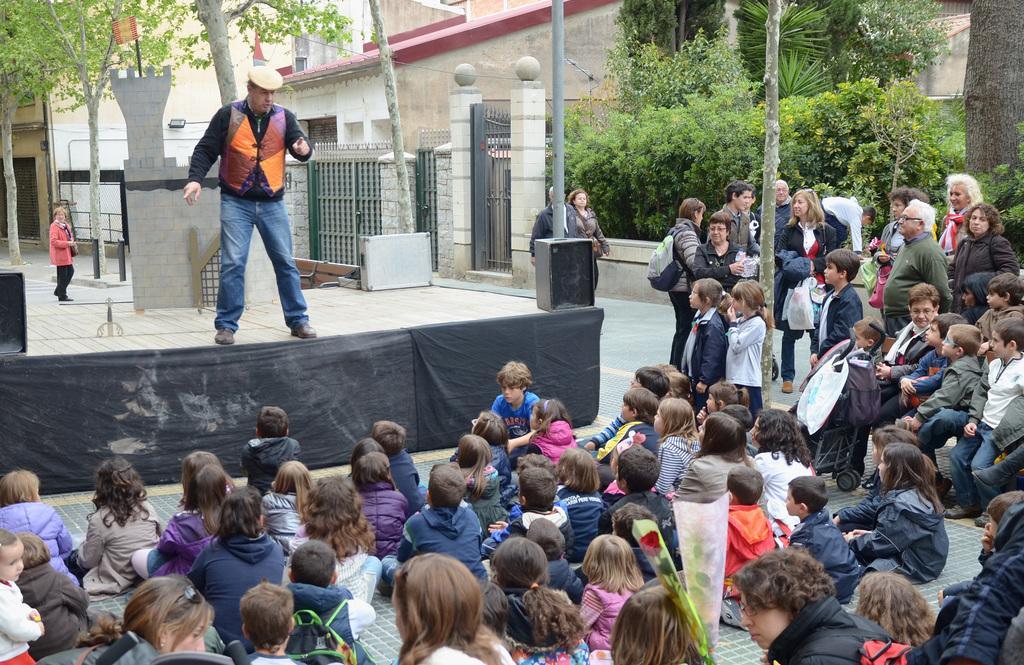In one or two sentences, can you explain what this image depicts? In this image some people are sitting on floor and some people are sitting on chairs and in front of them there is a person standing on stage and he is talking and at the right side of the image there are trees and we can see buildings on right side of the image. 